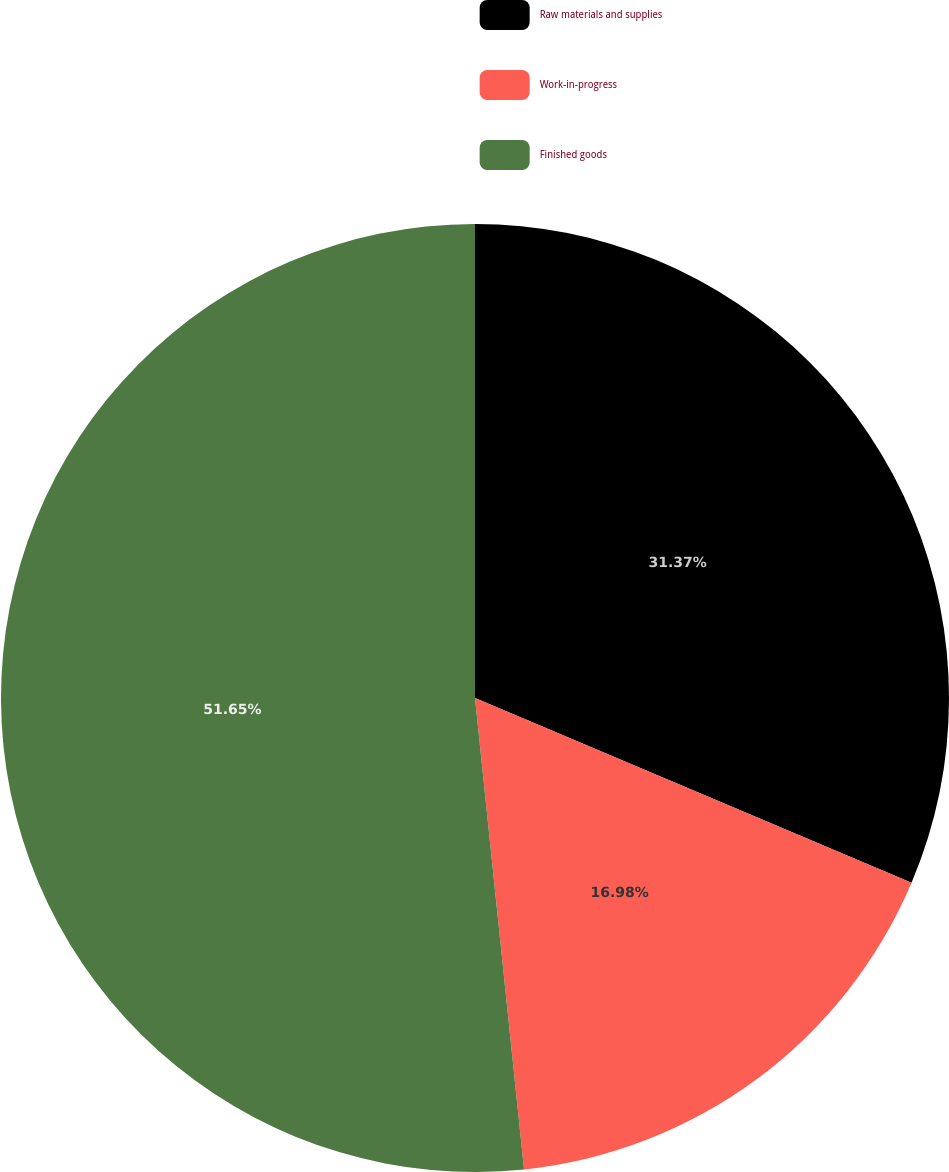Convert chart. <chart><loc_0><loc_0><loc_500><loc_500><pie_chart><fcel>Raw materials and supplies<fcel>Work-in-progress<fcel>Finished goods<nl><fcel>31.37%<fcel>16.98%<fcel>51.65%<nl></chart> 